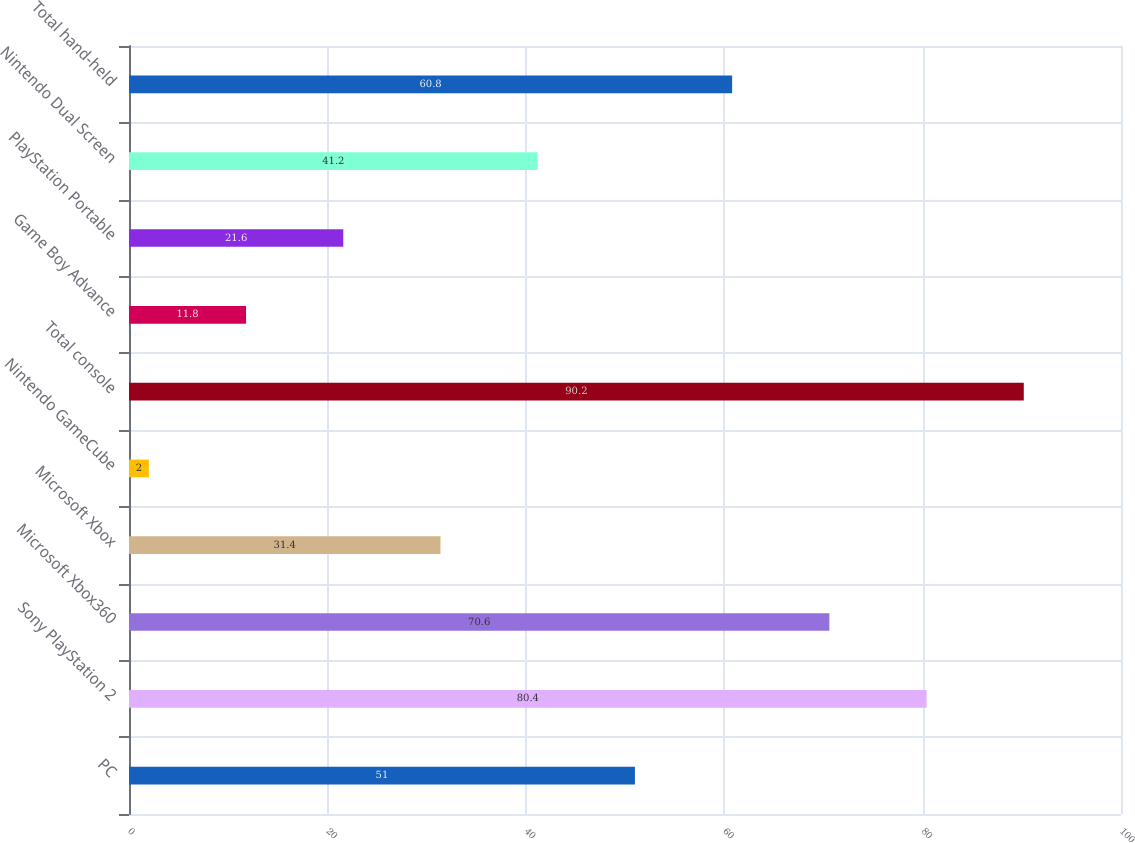Convert chart to OTSL. <chart><loc_0><loc_0><loc_500><loc_500><bar_chart><fcel>PC<fcel>Sony PlayStation 2<fcel>Microsoft Xbox360<fcel>Microsoft Xbox<fcel>Nintendo GameCube<fcel>Total console<fcel>Game Boy Advance<fcel>PlayStation Portable<fcel>Nintendo Dual Screen<fcel>Total hand-held<nl><fcel>51<fcel>80.4<fcel>70.6<fcel>31.4<fcel>2<fcel>90.2<fcel>11.8<fcel>21.6<fcel>41.2<fcel>60.8<nl></chart> 